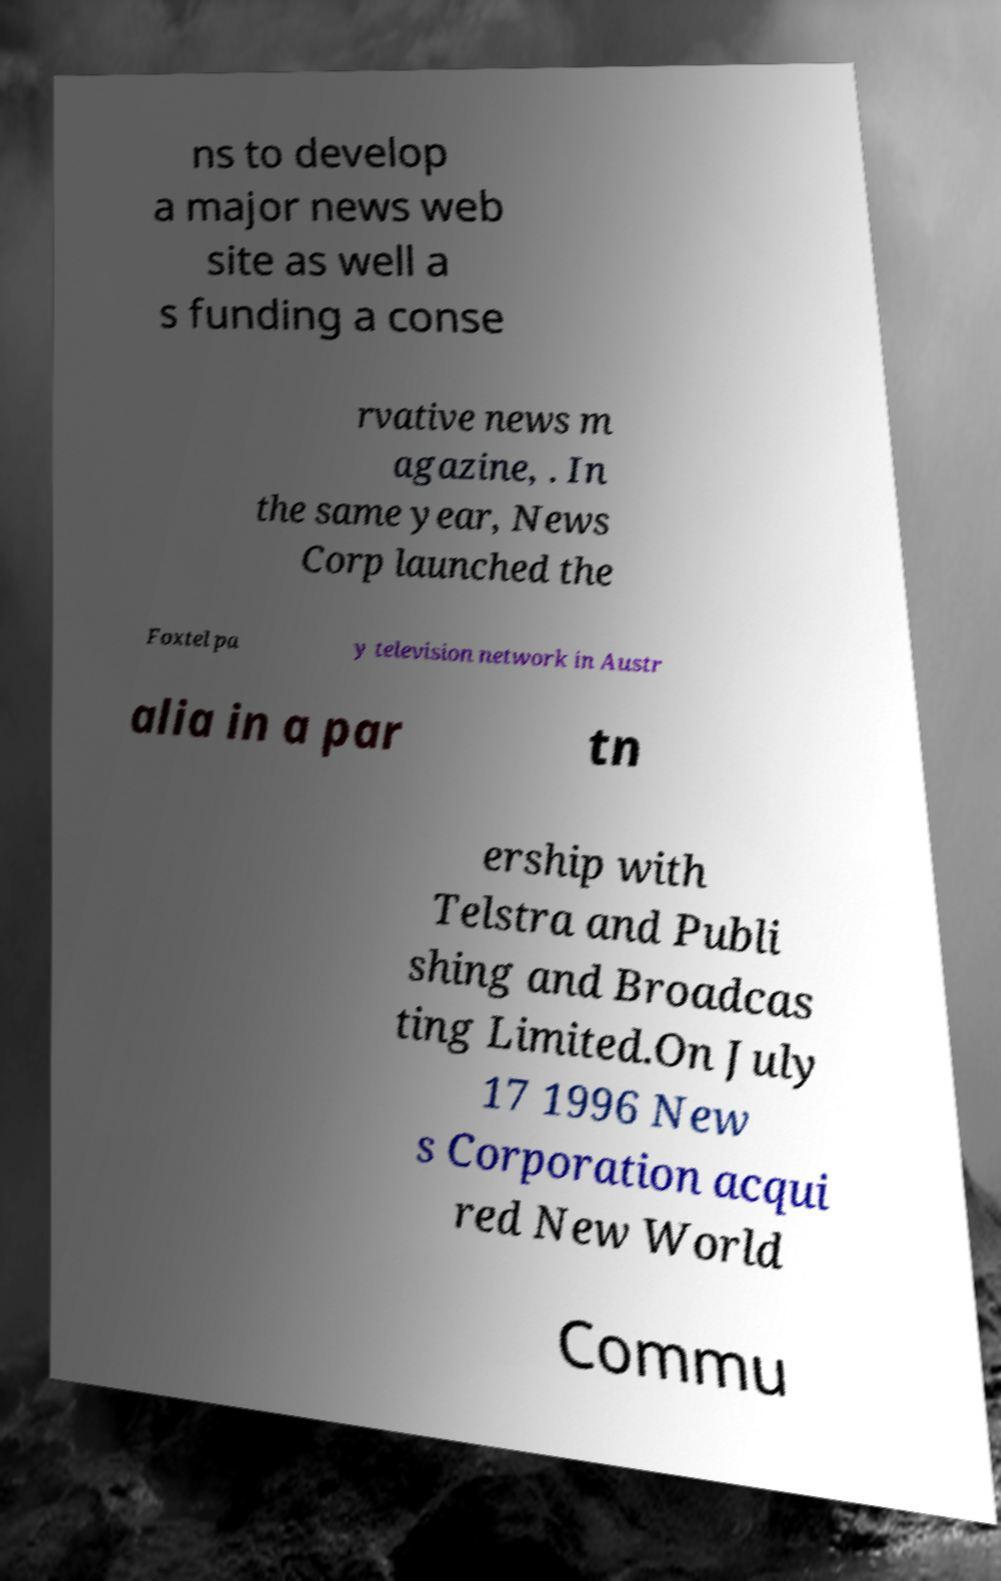For documentation purposes, I need the text within this image transcribed. Could you provide that? ns to develop a major news web site as well a s funding a conse rvative news m agazine, . In the same year, News Corp launched the Foxtel pa y television network in Austr alia in a par tn ership with Telstra and Publi shing and Broadcas ting Limited.On July 17 1996 New s Corporation acqui red New World Commu 